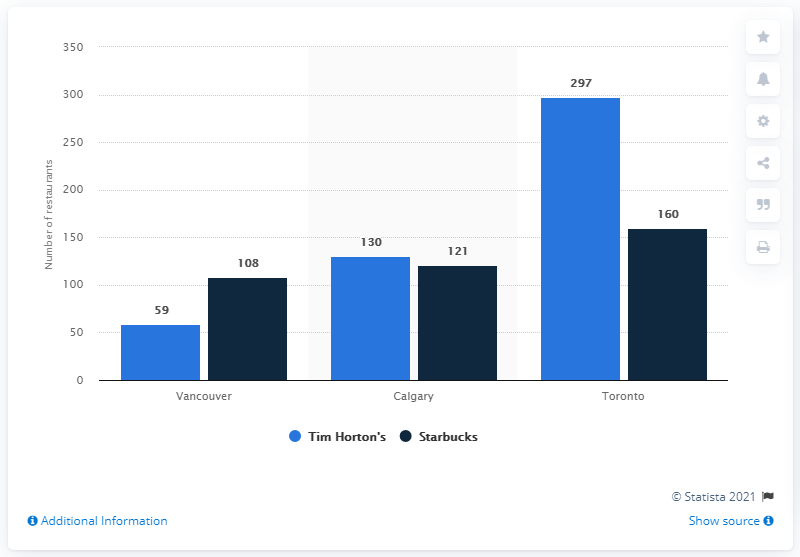Does this image provide any source information for the data presented? Indeed, the chart includes a reference to 'Statista 2021' as the source of the data, indicating that the information was gathered and processed by the Statista company in the year 2021. 